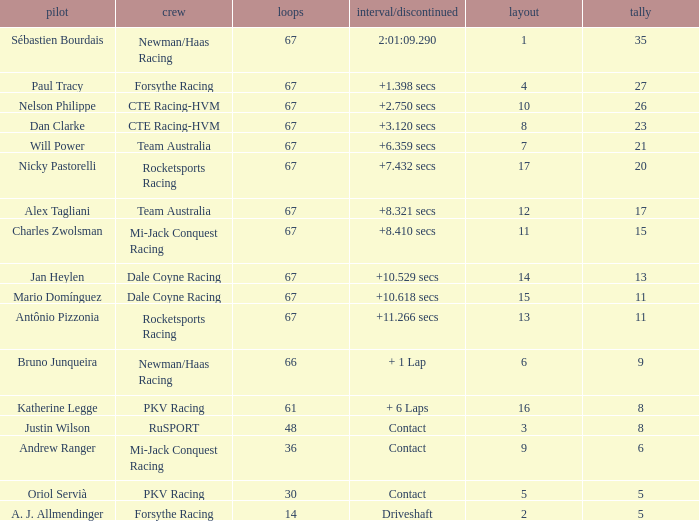What was time/retired with less than 67 laps and 6 points? Contact. 